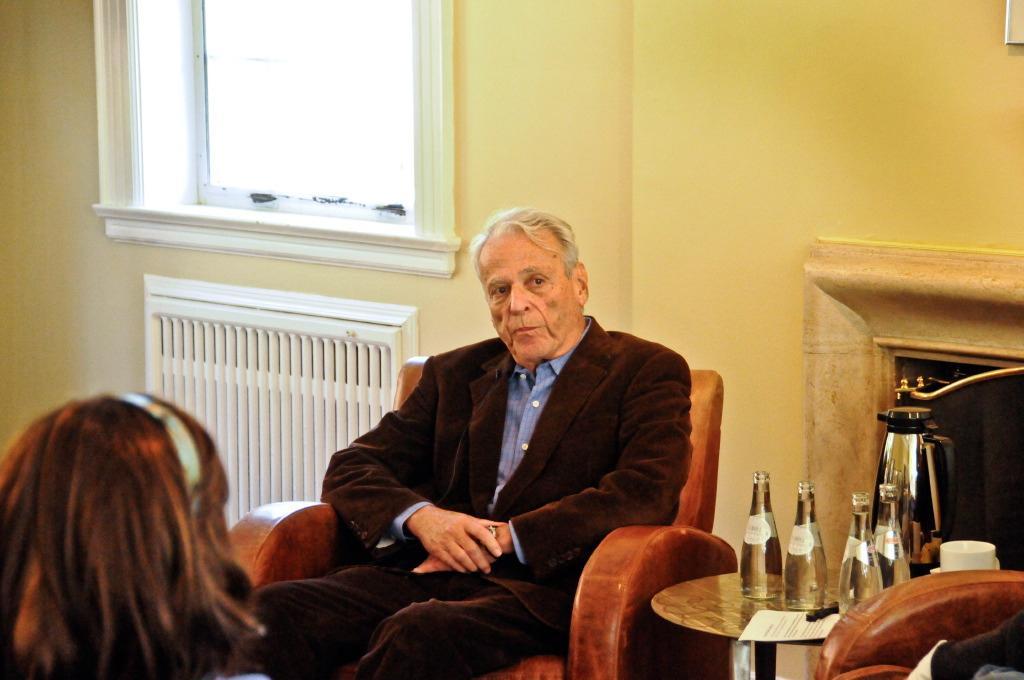Please provide a concise description of this image. As we can see in the image there is a yellow color wall, window, two people sitting on sofas and a table. On table there are bottles and cup. 